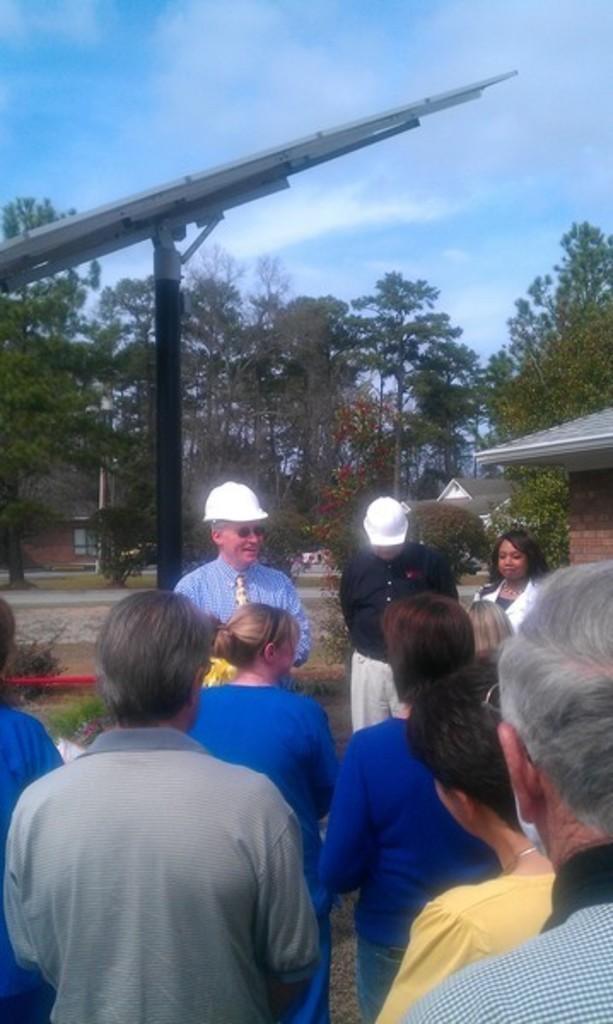In one or two sentences, can you explain what this image depicts? In this image I can see few people are standing, I can also see two of them are wearing white colour helmets. In background I can see number of trees, clouds, the sky and grass. 